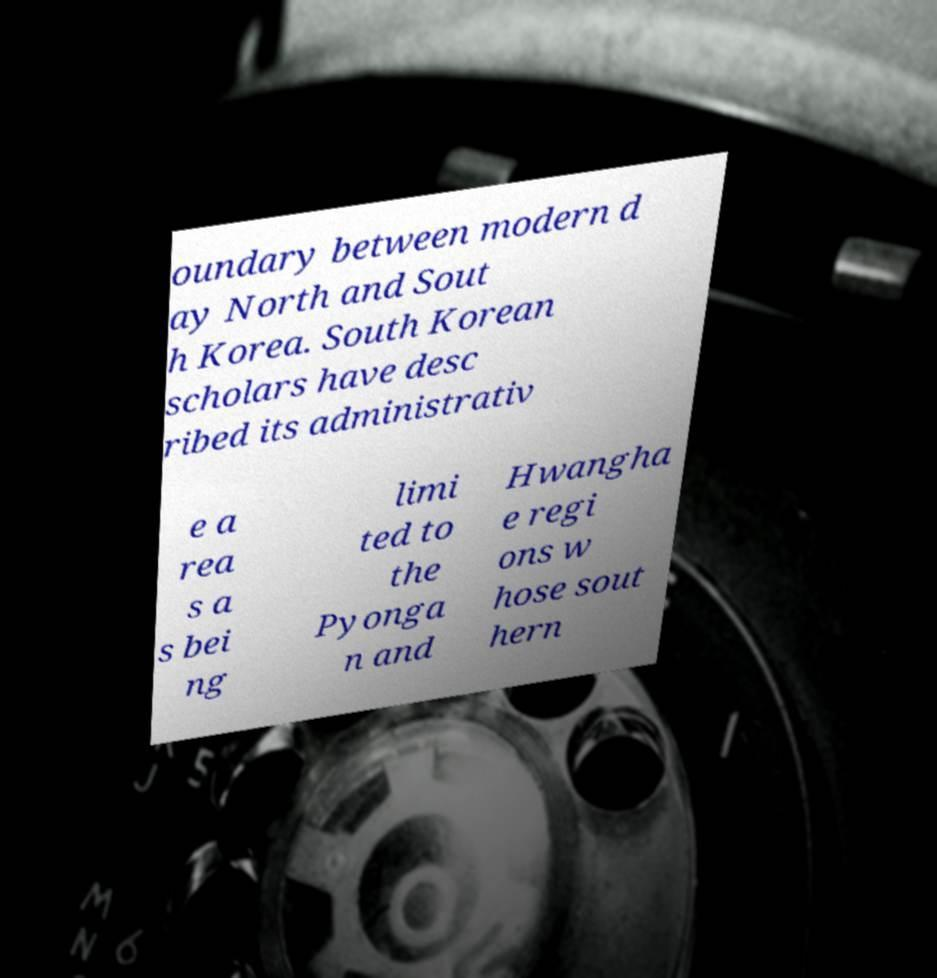Please read and relay the text visible in this image. What does it say? oundary between modern d ay North and Sout h Korea. South Korean scholars have desc ribed its administrativ e a rea s a s bei ng limi ted to the Pyonga n and Hwangha e regi ons w hose sout hern 